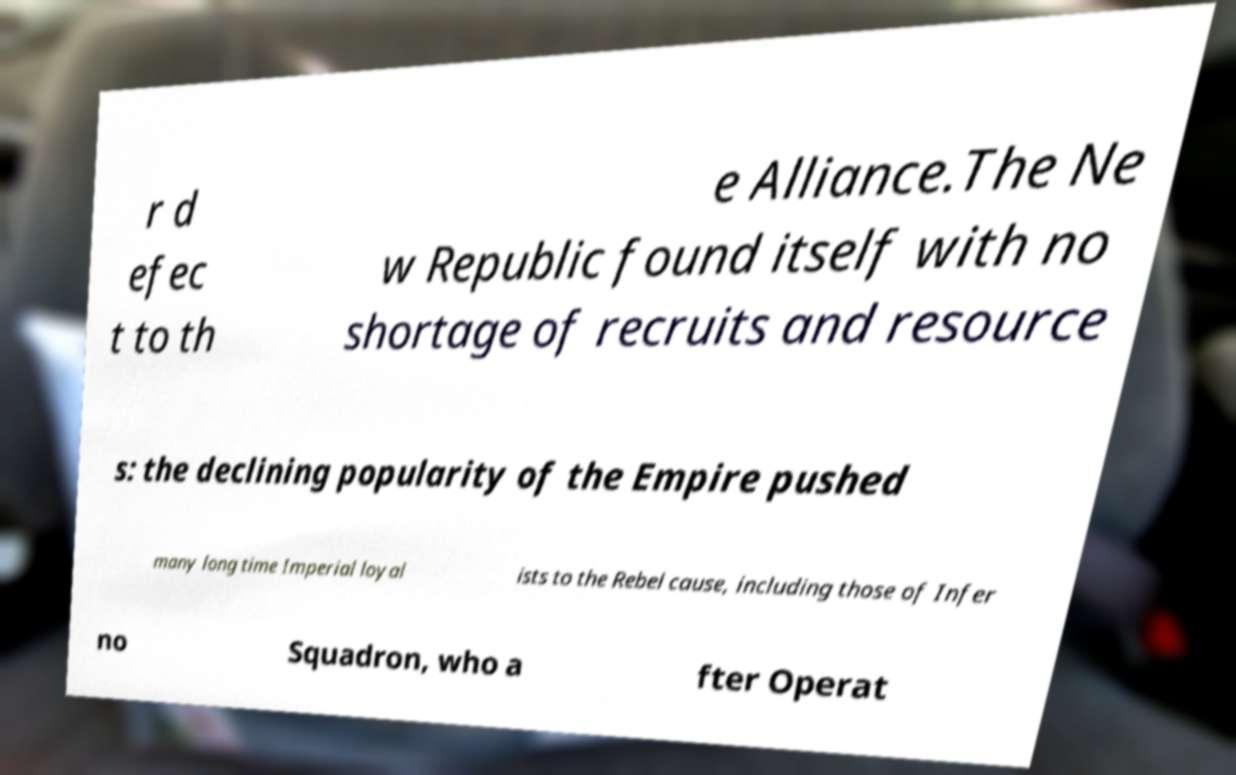Can you accurately transcribe the text from the provided image for me? r d efec t to th e Alliance.The Ne w Republic found itself with no shortage of recruits and resource s: the declining popularity of the Empire pushed many long time Imperial loyal ists to the Rebel cause, including those of Infer no Squadron, who a fter Operat 